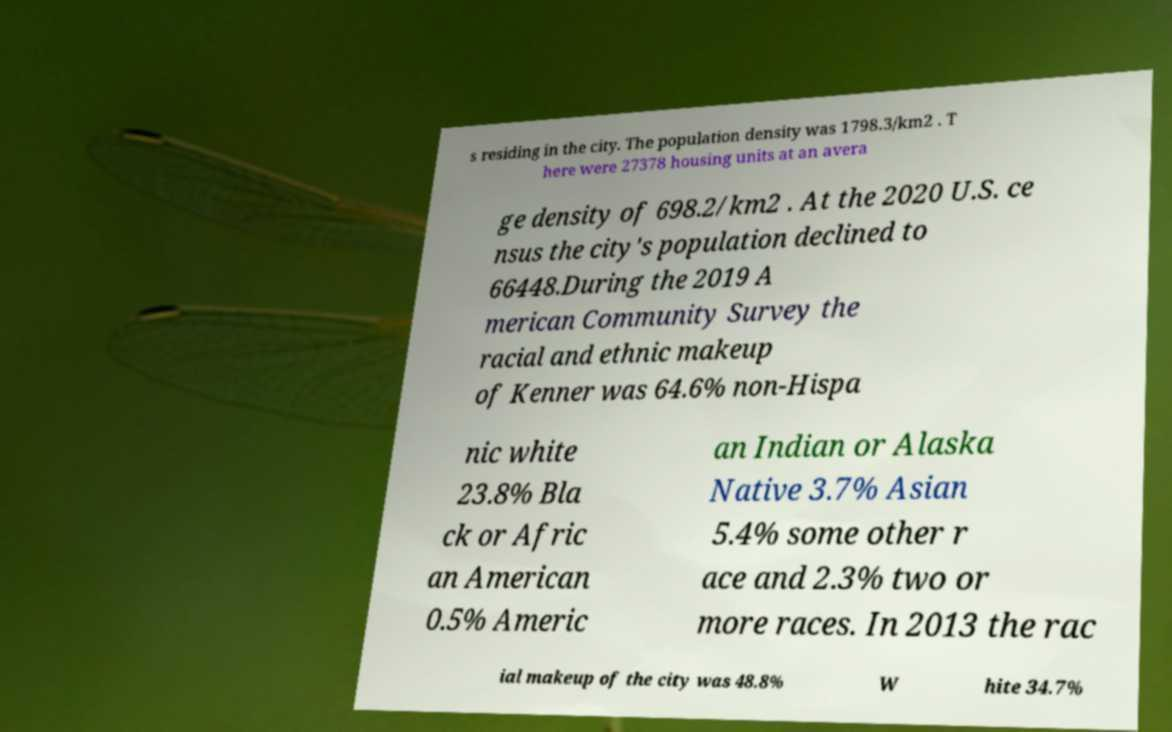There's text embedded in this image that I need extracted. Can you transcribe it verbatim? s residing in the city. The population density was 1798.3/km2 . T here were 27378 housing units at an avera ge density of 698.2/km2 . At the 2020 U.S. ce nsus the city's population declined to 66448.During the 2019 A merican Community Survey the racial and ethnic makeup of Kenner was 64.6% non-Hispa nic white 23.8% Bla ck or Afric an American 0.5% Americ an Indian or Alaska Native 3.7% Asian 5.4% some other r ace and 2.3% two or more races. In 2013 the rac ial makeup of the city was 48.8% W hite 34.7% 